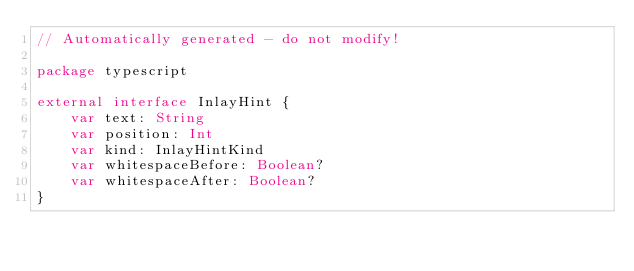Convert code to text. <code><loc_0><loc_0><loc_500><loc_500><_Kotlin_>// Automatically generated - do not modify!

package typescript

external interface InlayHint {
    var text: String
    var position: Int
    var kind: InlayHintKind
    var whitespaceBefore: Boolean?
    var whitespaceAfter: Boolean?
}
</code> 